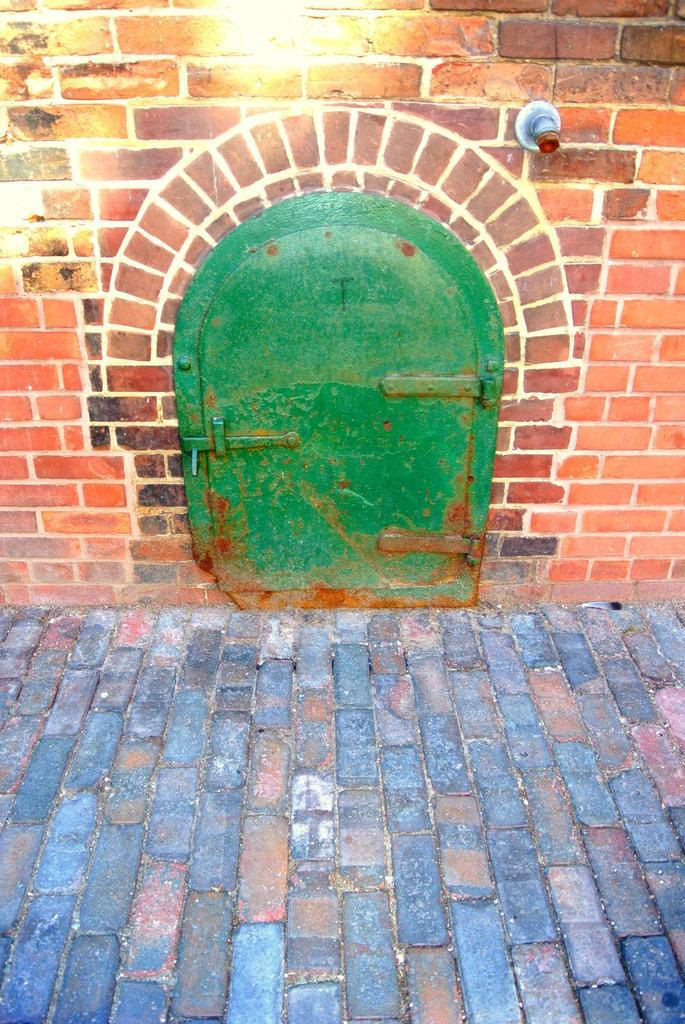What is the main feature of the image? There is a door in the image. What color is the door? The door is green. What type of wall is next to the door? There is a red brick wall in the image, and it is to the side of the door. What can be seen in the background of the image? There is a road visible in the image. What type of authority figure can be seen standing next to the door in the image? There is no authority figure present in the image. What kind of quartz is used as a decorative element in the image? There is no quartz present in the image. 